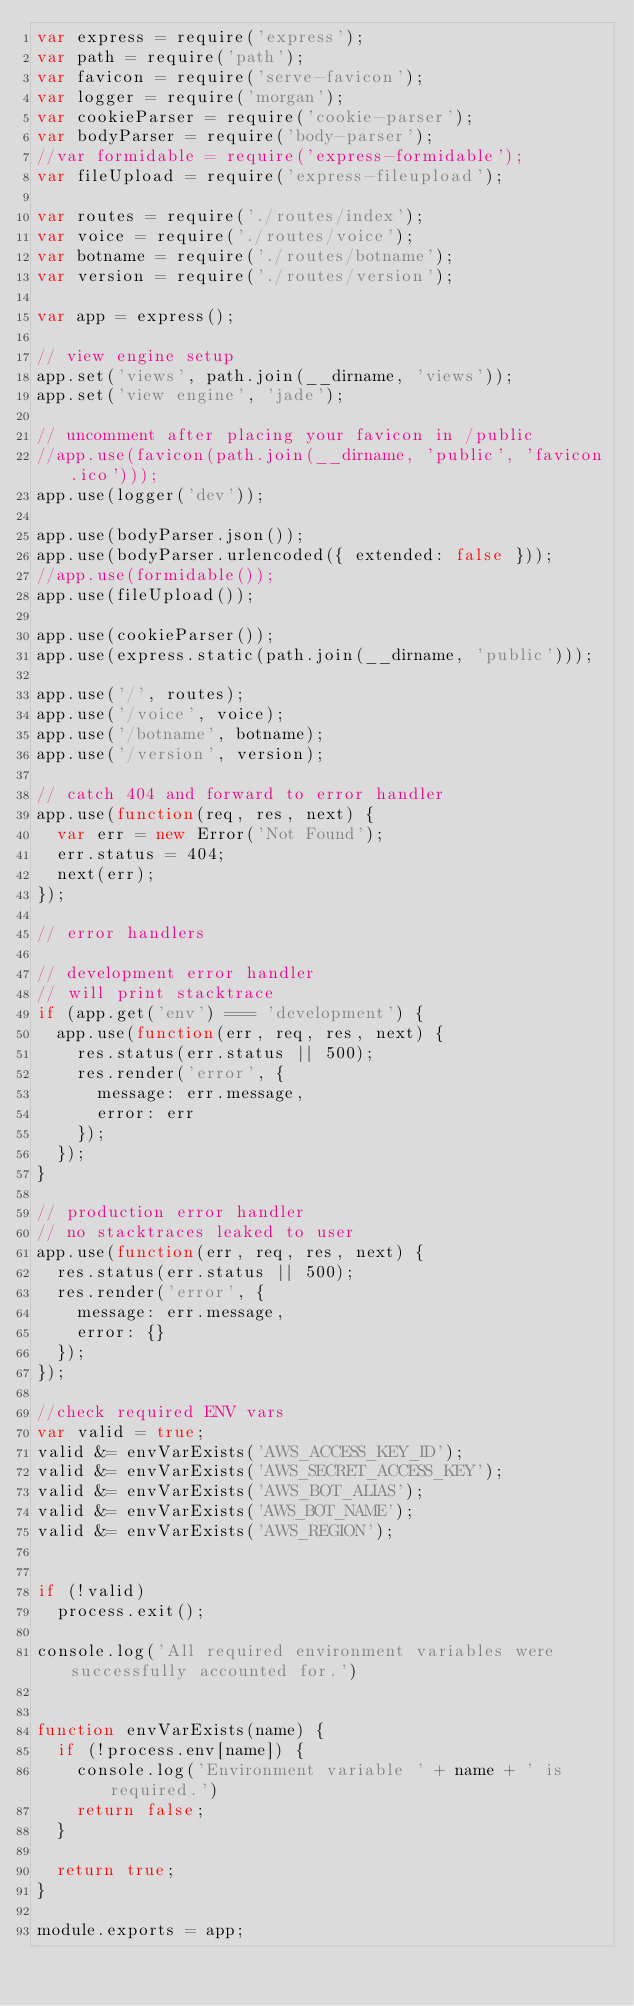<code> <loc_0><loc_0><loc_500><loc_500><_JavaScript_>var express = require('express');
var path = require('path');
var favicon = require('serve-favicon');
var logger = require('morgan');
var cookieParser = require('cookie-parser');
var bodyParser = require('body-parser');
//var formidable = require('express-formidable');
var fileUpload = require('express-fileupload');

var routes = require('./routes/index');
var voice = require('./routes/voice');
var botname = require('./routes/botname');
var version = require('./routes/version');

var app = express();

// view engine setup
app.set('views', path.join(__dirname, 'views'));
app.set('view engine', 'jade');

// uncomment after placing your favicon in /public
//app.use(favicon(path.join(__dirname, 'public', 'favicon.ico')));
app.use(logger('dev'));

app.use(bodyParser.json());
app.use(bodyParser.urlencoded({ extended: false }));
//app.use(formidable());
app.use(fileUpload());

app.use(cookieParser());
app.use(express.static(path.join(__dirname, 'public')));

app.use('/', routes);
app.use('/voice', voice);
app.use('/botname', botname);
app.use('/version', version);

// catch 404 and forward to error handler
app.use(function(req, res, next) {
  var err = new Error('Not Found');
  err.status = 404;
  next(err);
});

// error handlers

// development error handler
// will print stacktrace
if (app.get('env') === 'development') {
  app.use(function(err, req, res, next) {
    res.status(err.status || 500);
    res.render('error', {
      message: err.message,
      error: err
    });
  });
}

// production error handler
// no stacktraces leaked to user
app.use(function(err, req, res, next) {
  res.status(err.status || 500);
  res.render('error', {
    message: err.message,
    error: {}
  });
});

//check required ENV vars
var valid = true;
valid &= envVarExists('AWS_ACCESS_KEY_ID');
valid &= envVarExists('AWS_SECRET_ACCESS_KEY');
valid &= envVarExists('AWS_BOT_ALIAS');
valid &= envVarExists('AWS_BOT_NAME');
valid &= envVarExists('AWS_REGION');


if (!valid)
  process.exit();

console.log('All required environment variables were successfully accounted for.')


function envVarExists(name) {
  if (!process.env[name]) {
    console.log('Environment variable ' + name + ' is required.')
    return false;
  }

  return true;
}

module.exports = app;
</code> 